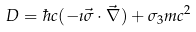Convert formula to latex. <formula><loc_0><loc_0><loc_500><loc_500>D = \hbar { c } ( - \imath \vec { \sigma } \cdot \vec { \nabla } ) + \sigma _ { 3 } m c ^ { 2 }</formula> 